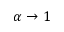Convert formula to latex. <formula><loc_0><loc_0><loc_500><loc_500>\alpha \rightarrow 1</formula> 